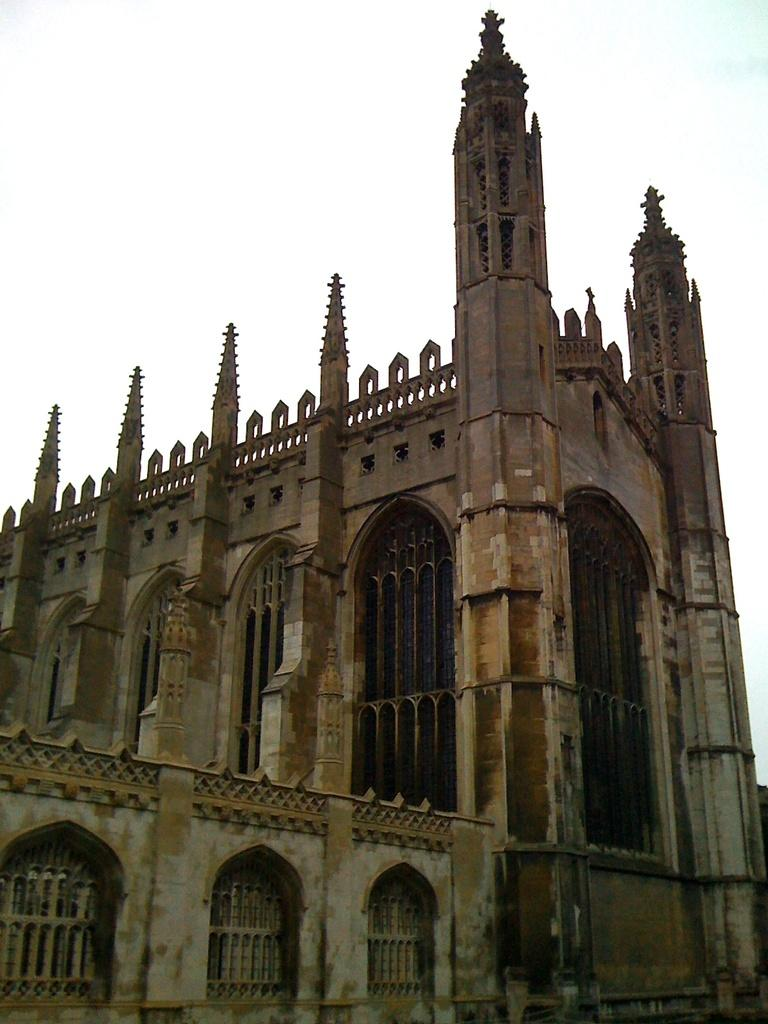What type of structure is present in the image? There is a building in the image. What feature can be seen on the building? The building has windows. What is visible at the top of the image? The sky is visible at the top of the image. How many giraffes can be seen roaming the territory in the image? There are no giraffes or territory present in the image; it features a building with windows and a visible sky. 